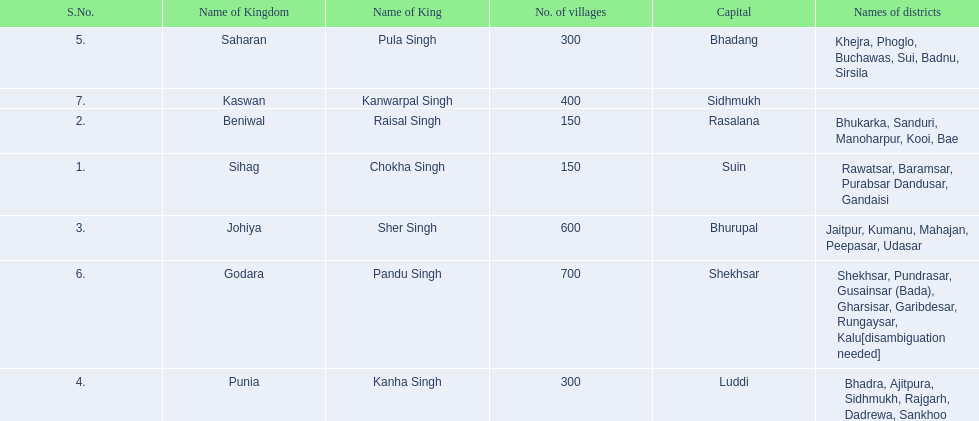Which kingdom contained the least amount of villages along with sihag? Beniwal. Which kingdom contained the most villages? Godara. Which village was tied at second most villages with godara? Johiya. 